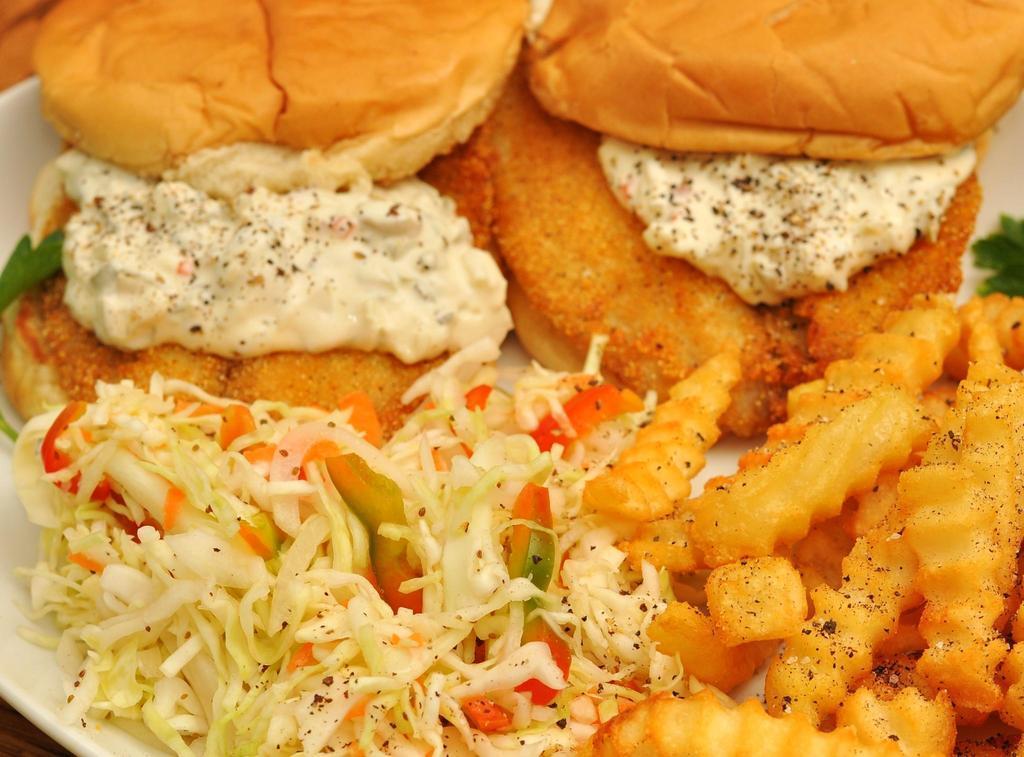Could you give a brief overview of what you see in this image? In this image we can see some food on the white plate and one object in the top left side corner of the image. 